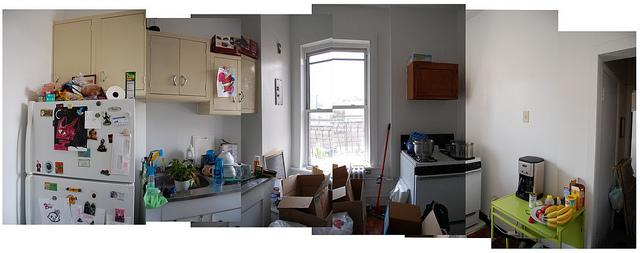How my different pictures are in this photo?
Concise answer only. 5. Does this kitchen look lived in?
Answer briefly. Yes. Is there anything on the refrigerator door?
Short answer required. Yes. What room in the house is this picture taken?
Be succinct. Kitchen. Is the window opened or closed?
Give a very brief answer. Closed. 